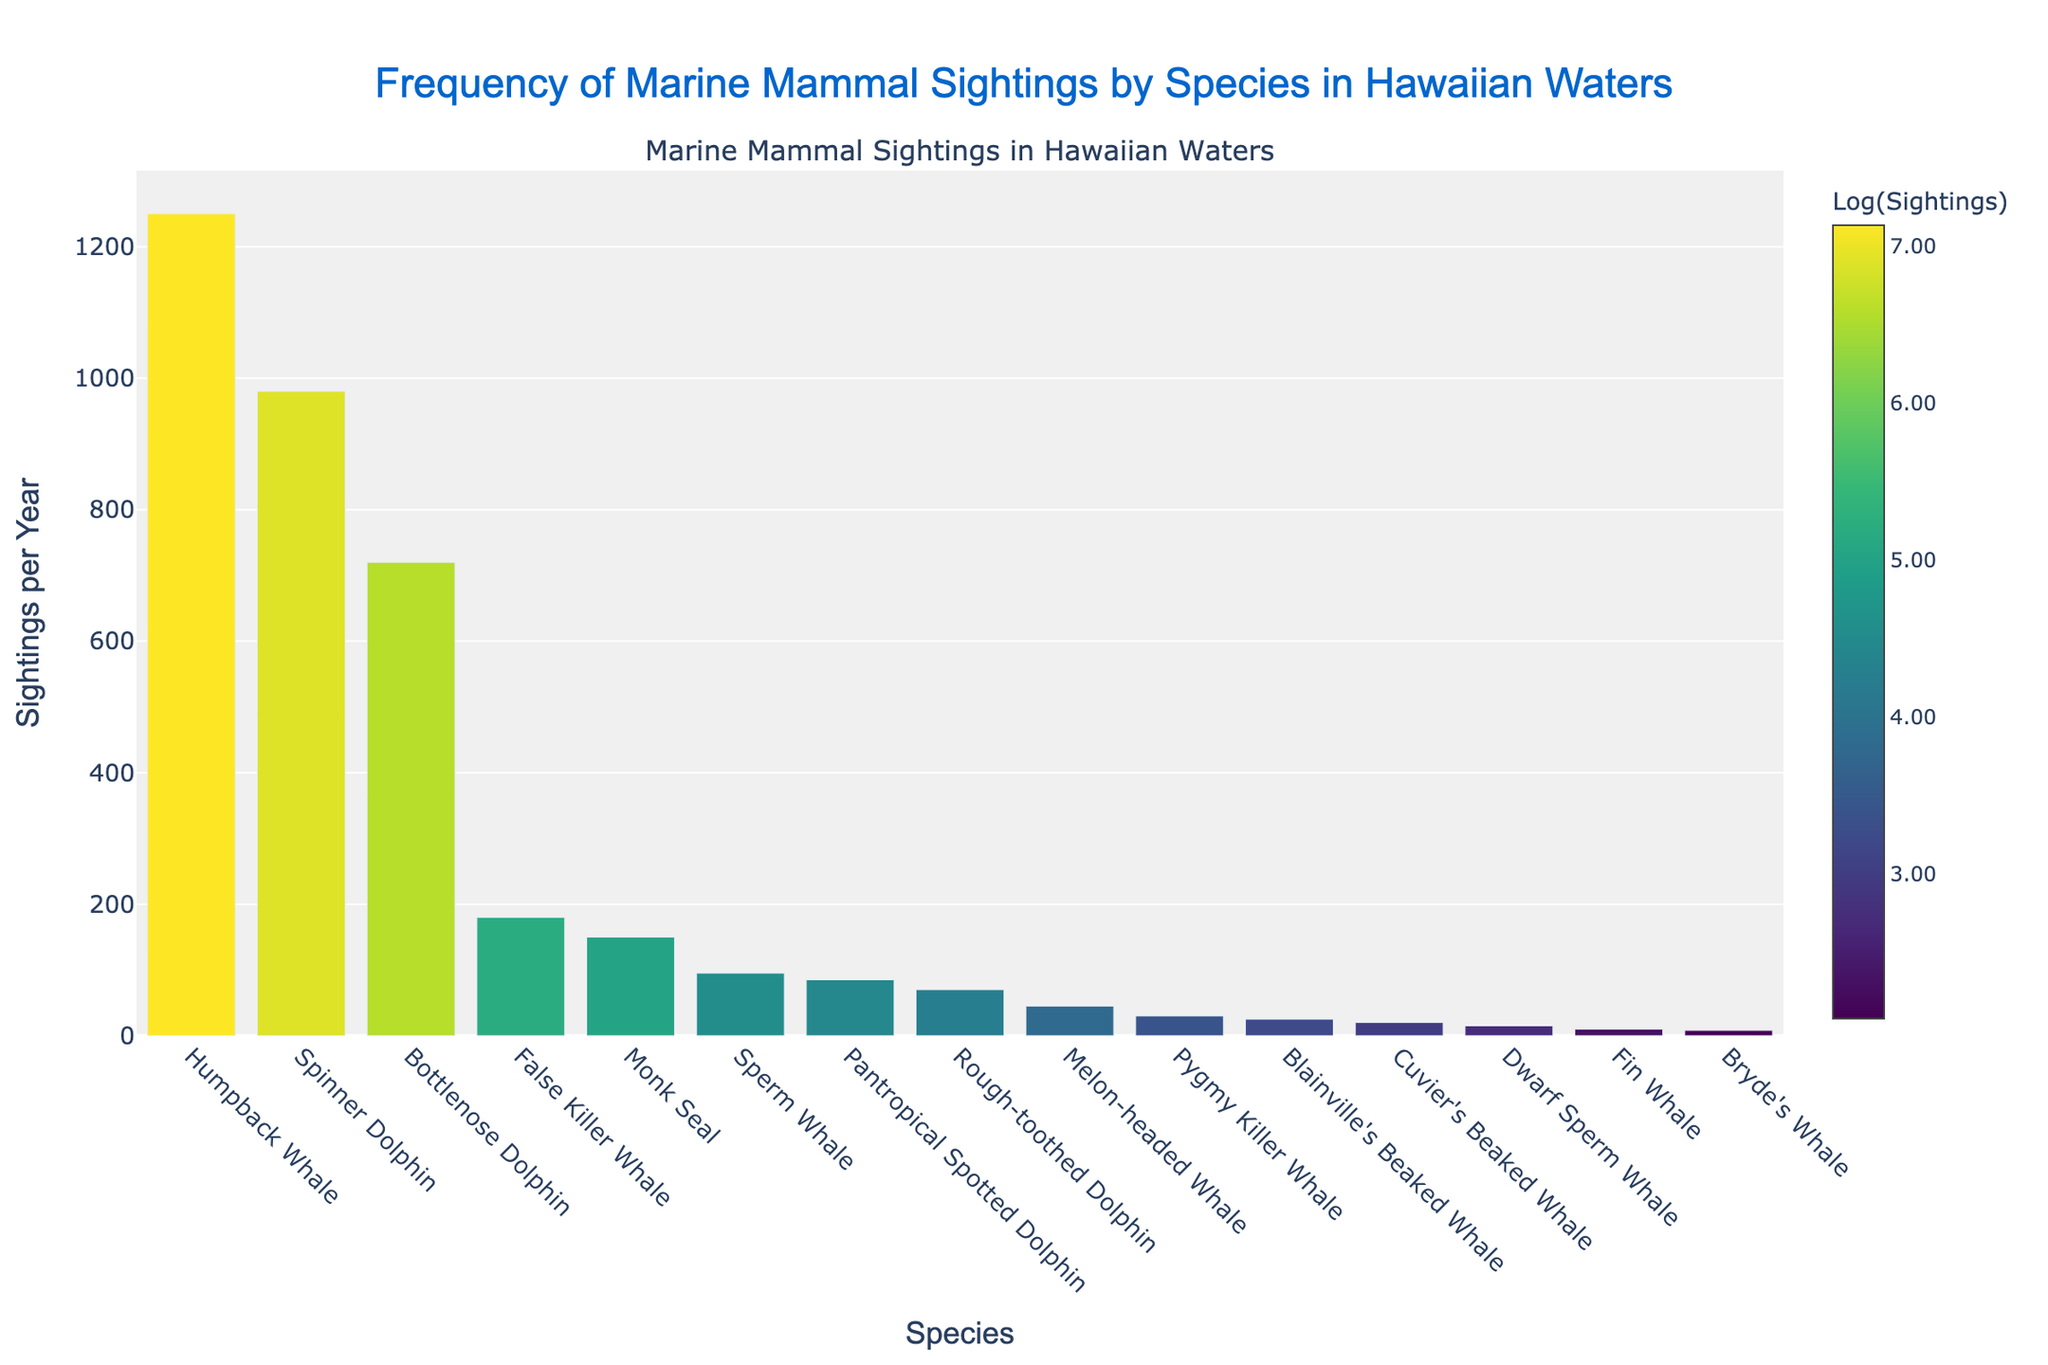What species has the highest number of sightings per year? The species with the highest number of sightings has the tallest bar in the bar chart. The Humpback Whale's bar is the tallest, indicating it has the most sightings.
Answer: Humpback Whale What species has the lowest number of sightings per year? The species with the lowest number of sightings has the shortest bar in the bar chart. The Dwarf Sperm Whale's bar is the shortest.
Answer: Dwarf Sperm Whale What is the difference in the number of sightings between Bottlenose Dolphin and False Killer Whale? Locate the heights of the bars for Bottlenose Dolphin (720 sightings) and False Killer Whale (180 sightings). Subtract the smaller number from the larger number, 720 - 180.
Answer: 540 How many more sightings do Monk Seals have compared to Pygmy Killer Whales? Locate the heights of the bars for Monk Seals (150 sightings) and Pygmy Killer Whales (30 sightings). Subtract the number of Pygmy Killer Whale sightings from Monk Seal sightings, 150 - 30.
Answer: 120 Which species has fewer sightings: Spinner Dolphin or Melon-headed Whale? Compare the heights of the bars representing Spinner Dolphin (980 sightings) and Melon-headed Whale (45 sightings). The Melon-headed Whale's bar is shorter.
Answer: Melon-headed Whale What is the sum of sightings for the top three species? Identify the top three species by the height of their bars: Humpback Whale (1250), Spinner Dolphin (980), and Bottlenose Dolphin (720). Add these numbers together, 1250 + 980 + 720.
Answer: 2950 Which species has approximately half as many sightings as Bottlenose Dolphin? Bottlenose Dolphin has 720 sightings. Look for a bar with about half this number, around 360. False Killer Whale has 180 sightings, which is closest to half of 720 but less than the exact half.
Answer: False Killer Whale How many species have more than 100 sightings per year? Count the species with bars representing more than 100 sightings. These are Humpback Whale, Spinner Dolphin, Bottlenose Dolphin, False Killer Whale, Monk Seal.
Answer: 5 Which species are sighted more frequently: False Killer Whale or Monk Seal? Compare the heights of the bars for False Killer Whale (180 sightings) and Monk Seal (150 sightings). The False Killer Whale's bar is taller.
Answer: False Killer Whale What's the average number of sightings per year for the species with more than 500 sightings? Identify species with more than 500 sightings per year: Humpback Whale (1250), Spinner Dolphin (980), Bottlenose Dolphin (720). Sum these sightings and divide by the number of these species: (1250 + 980 + 720) / 3.
Answer: 983.33 